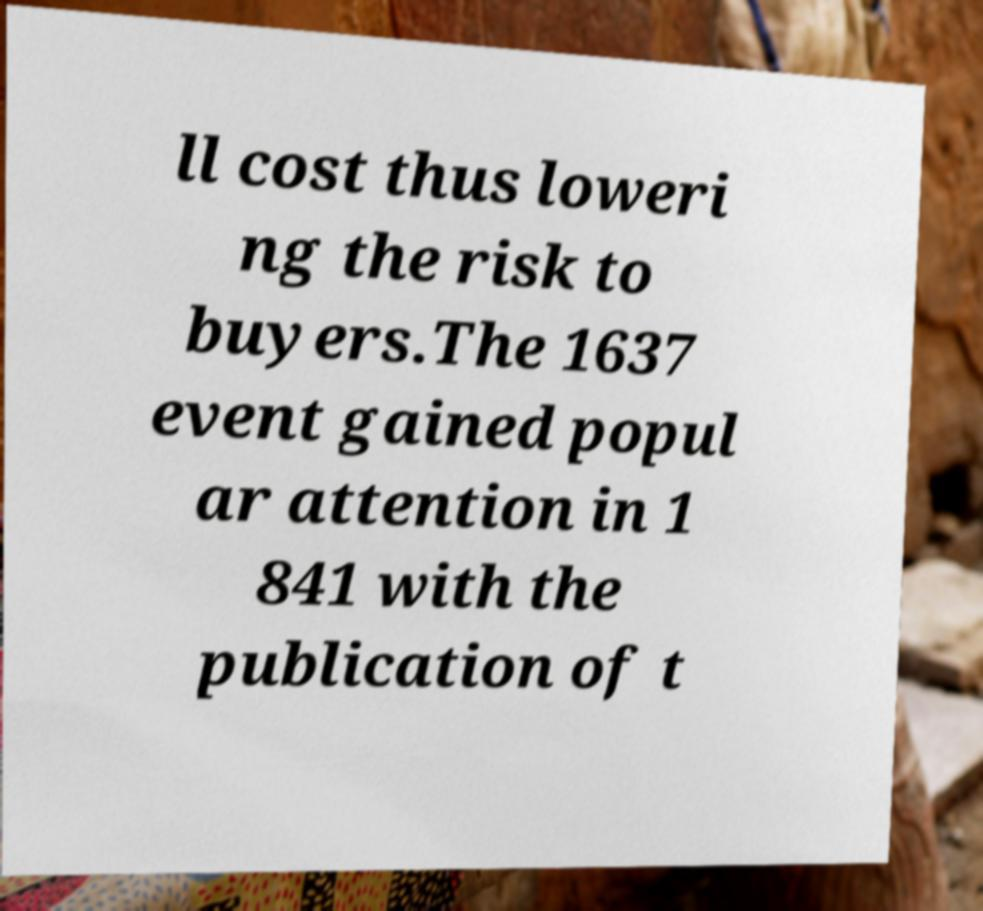Can you read and provide the text displayed in the image?This photo seems to have some interesting text. Can you extract and type it out for me? ll cost thus loweri ng the risk to buyers.The 1637 event gained popul ar attention in 1 841 with the publication of t 